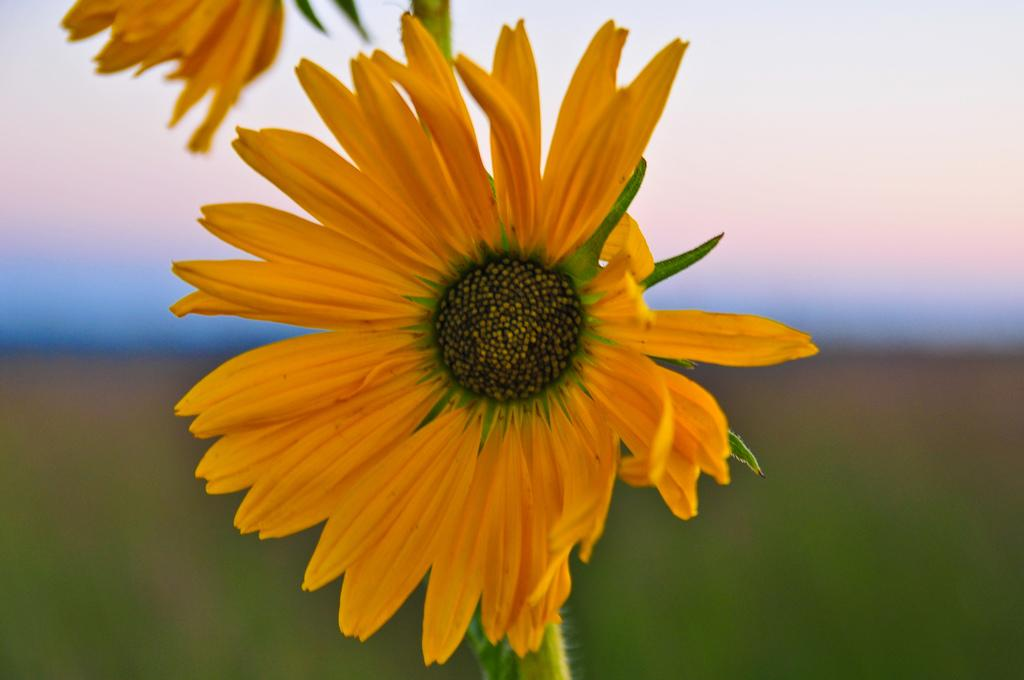What type of flowers can be seen in the image? There are two yellow flowers in the image. Can you describe the background of the image? The background of the image is blurred. What type of bell can be heard ringing in the image? There is no bell present in the image, and therefore no sound can be heard. 